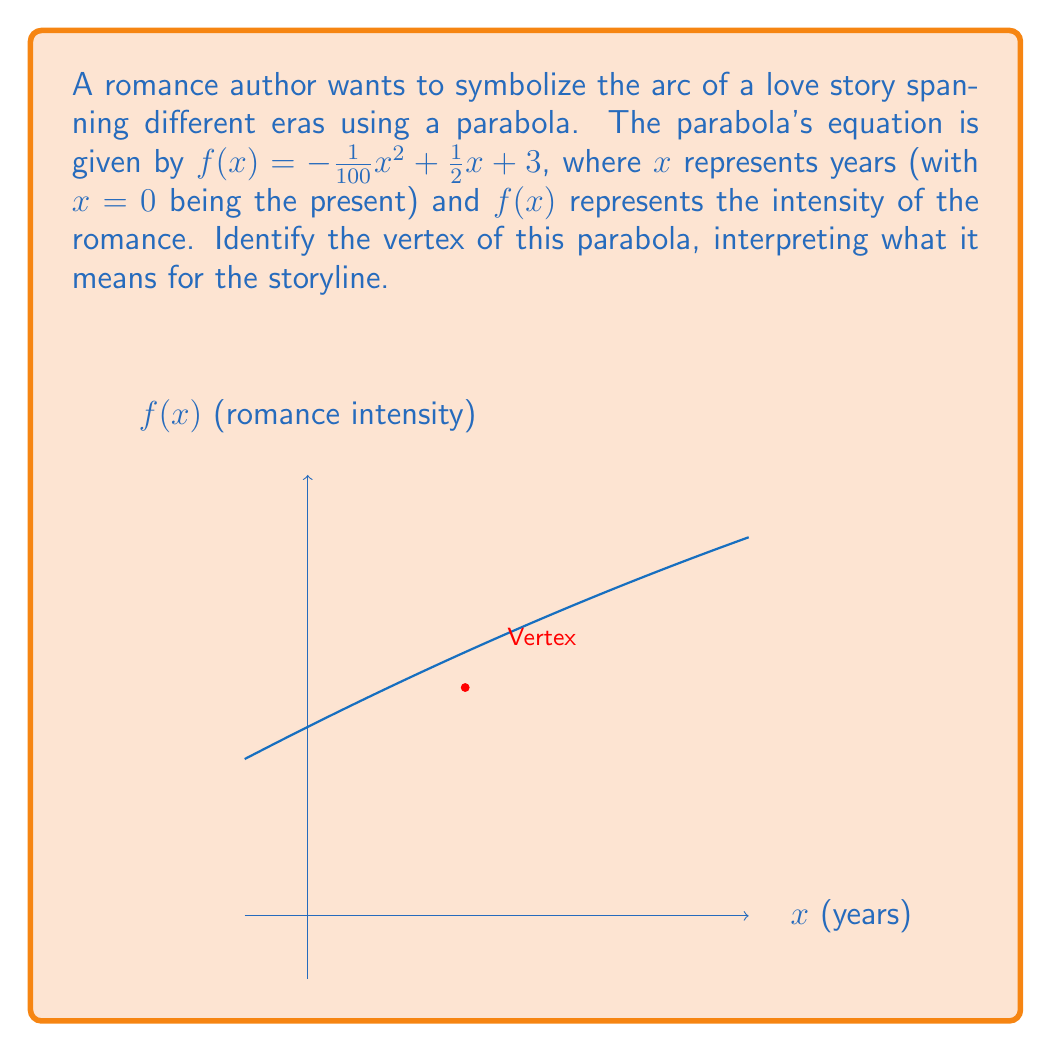What is the answer to this math problem? To find the vertex of the parabola, we'll follow these steps:

1) For a quadratic function in the form $f(x) = ax^2 + bx + c$, the x-coordinate of the vertex is given by $x = -\frac{b}{2a}$.

2) In our equation $f(x) = -\frac{1}{100}x^2 + \frac{1}{2}x + 3$:
   $a = -\frac{1}{100}$
   $b = \frac{1}{2}$

3) Substituting into the formula:
   $x = -\frac{\frac{1}{2}}{2(-\frac{1}{100})} = -\frac{\frac{1}{2}}{-\frac{1}{50}} = 25$

4) To find the y-coordinate, we substitute $x=25$ into the original equation:
   $f(25) = -\frac{1}{100}(25)^2 + \frac{1}{2}(25) + 3$
   $= -\frac{625}{100} + \frac{25}{2} + 3$
   $= -6.25 + 12.5 + 3 = 9.25$

5) Therefore, the vertex is (25, 9.25).

Interpretation: The vertex occurs 25 years in the future (x=25) from the present (x=0). This is the point where the romance reaches its peak intensity of 9.25. The parabola's shape suggests that the romance builds up to this point and then gradually decreases, symbolizing a love story that spans across different time periods, reaching its climax 25 years from the present.
Answer: (25, 9.25) 